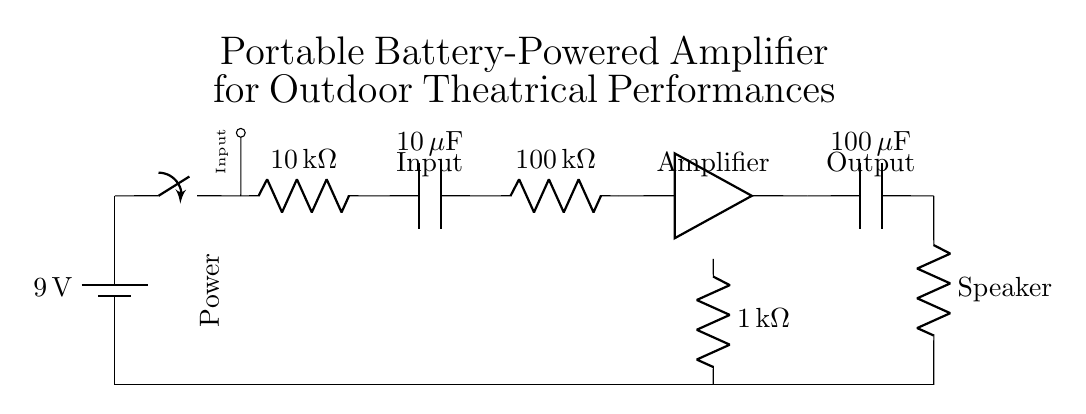What is the input voltage of this amplifier circuit? The input voltage is provided by the battery, which shows a potential of 9 volts at the source.
Answer: 9 volts What type of switch is used in this circuit? The circuit diagram indicates the presence of a switch component, specifically a power switch, typically represented as a simple toggle or push switch in these diagrams.
Answer: Power switch What is the resistance of the first resistor in the input stage? The diagram shows a resistor labeled with a value of 10 kilohms connecting the power switch to the next component in the input stage.
Answer: 10 kilohms How many capacitors are present in the output stage? Observing the output stage reveals one capacitor connected in series with the load (speaker) indicating that only one capacitor exists in that section of the circuit.
Answer: One capacitor What is the load impedance of the speaker? The output stage of the circuit specifically shows a load connected to the amplifier which has a resistance marked as 8 ohms, indicating the impedance of the speaker.
Answer: 8 ohms What is the purpose of the 100 microfarad capacitor in this circuit? The 100 microfarad capacitor positioned in series with the speaker in the output stage serves to block DC while allowing AC signals to pass through, thus preventing DC from reaching the speaker and protecting it.
Answer: Coupling capacitor What is the function of the 1 kilohm resistor in this circuit? The 1 kilohm resistor is shown connected in parallel to the amplifier, primarily functioning as a feedback resistor to control gain and improve the linearity of the amplifier while stabilizing its performance.
Answer: Feedback resistor 